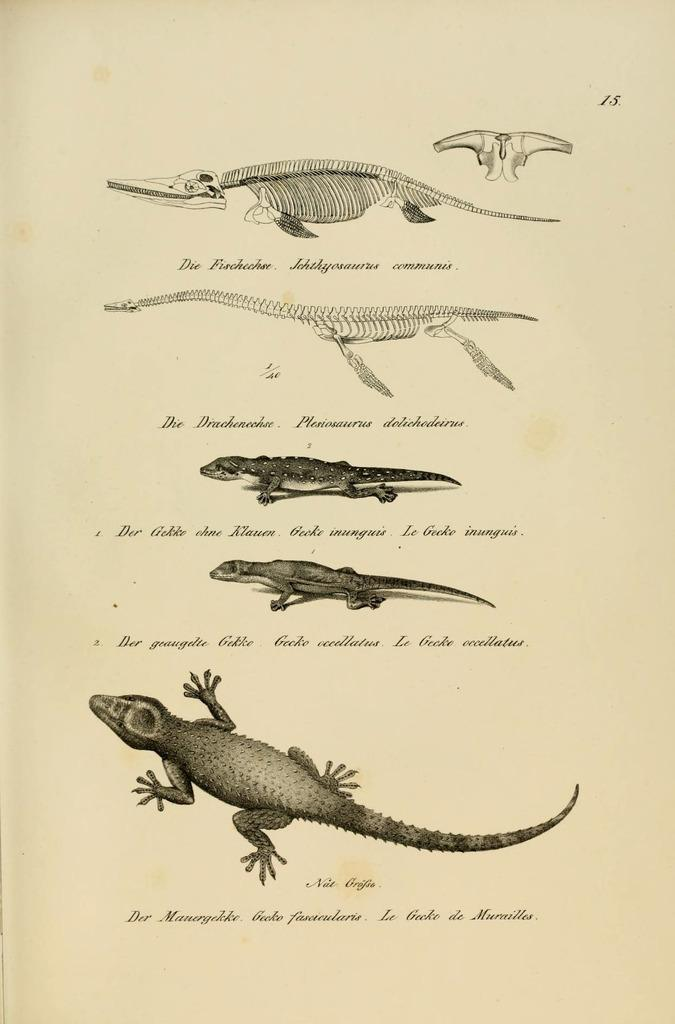What is present in the image? There is a paper in the image. What can be seen on the paper? The paper contains pictures of skeletons and reptiles. Are there any words or letters on the paper? Yes, there are letters written on the paper. What type of tub is visible in the image? There is no tub present in the image; it only contains a paper with pictures of skeletons and reptiles and letters. 